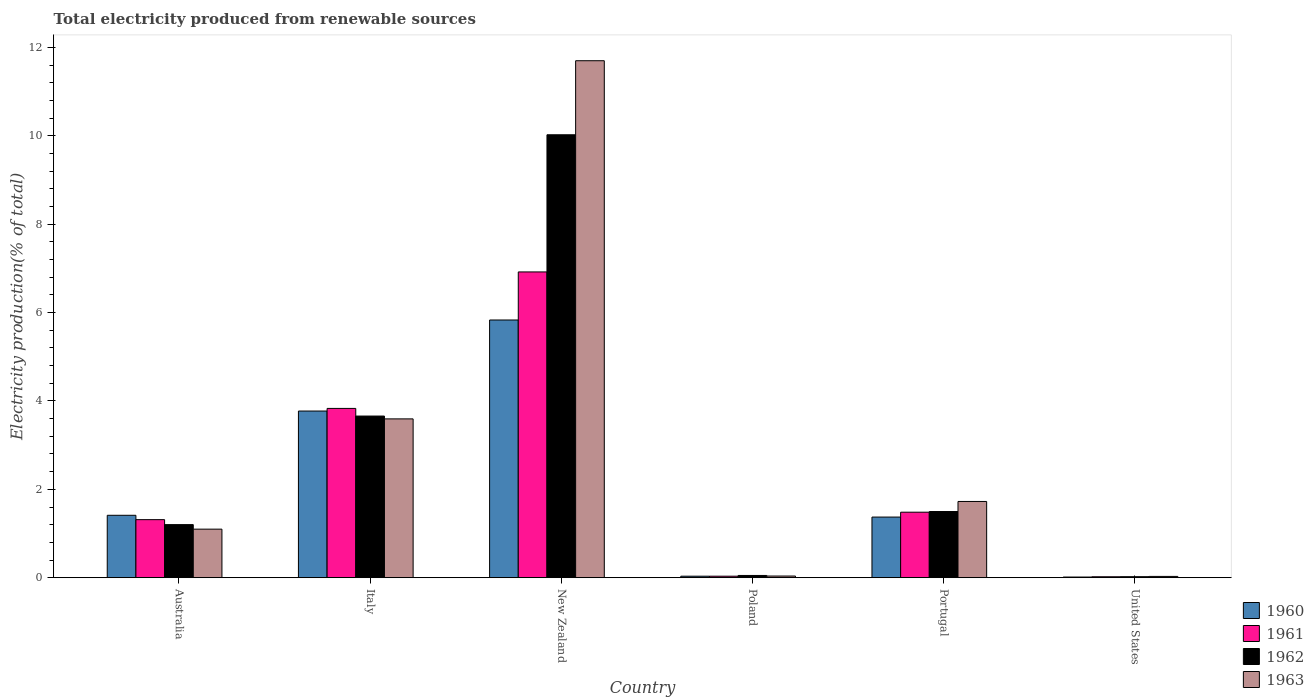How many different coloured bars are there?
Your answer should be very brief. 4. Are the number of bars per tick equal to the number of legend labels?
Your answer should be very brief. Yes. How many bars are there on the 3rd tick from the left?
Keep it short and to the point. 4. How many bars are there on the 6th tick from the right?
Give a very brief answer. 4. What is the label of the 1st group of bars from the left?
Your answer should be very brief. Australia. In how many cases, is the number of bars for a given country not equal to the number of legend labels?
Make the answer very short. 0. What is the total electricity produced in 1961 in United States?
Provide a short and direct response. 0.02. Across all countries, what is the maximum total electricity produced in 1962?
Your answer should be compact. 10.02. Across all countries, what is the minimum total electricity produced in 1963?
Offer a terse response. 0.03. In which country was the total electricity produced in 1961 maximum?
Offer a terse response. New Zealand. In which country was the total electricity produced in 1963 minimum?
Your answer should be very brief. United States. What is the total total electricity produced in 1961 in the graph?
Provide a succinct answer. 13.6. What is the difference between the total electricity produced in 1963 in Poland and that in Portugal?
Make the answer very short. -1.69. What is the difference between the total electricity produced in 1963 in Poland and the total electricity produced in 1960 in United States?
Offer a terse response. 0.02. What is the average total electricity produced in 1963 per country?
Provide a short and direct response. 3.03. What is the difference between the total electricity produced of/in 1961 and total electricity produced of/in 1963 in Poland?
Provide a succinct answer. -0. What is the ratio of the total electricity produced in 1962 in Australia to that in Italy?
Your response must be concise. 0.33. Is the difference between the total electricity produced in 1961 in Australia and New Zealand greater than the difference between the total electricity produced in 1963 in Australia and New Zealand?
Offer a terse response. Yes. What is the difference between the highest and the second highest total electricity produced in 1960?
Offer a terse response. -2.36. What is the difference between the highest and the lowest total electricity produced in 1960?
Make the answer very short. 5.82. In how many countries, is the total electricity produced in 1962 greater than the average total electricity produced in 1962 taken over all countries?
Offer a very short reply. 2. Is the sum of the total electricity produced in 1963 in Poland and United States greater than the maximum total electricity produced in 1962 across all countries?
Provide a succinct answer. No. Is it the case that in every country, the sum of the total electricity produced in 1962 and total electricity produced in 1960 is greater than the sum of total electricity produced in 1963 and total electricity produced in 1961?
Your response must be concise. No. What does the 1st bar from the right in Italy represents?
Your response must be concise. 1963. How many bars are there?
Provide a succinct answer. 24. What is the difference between two consecutive major ticks on the Y-axis?
Your answer should be very brief. 2. Are the values on the major ticks of Y-axis written in scientific E-notation?
Offer a terse response. No. Where does the legend appear in the graph?
Your answer should be very brief. Bottom right. How many legend labels are there?
Make the answer very short. 4. How are the legend labels stacked?
Provide a short and direct response. Vertical. What is the title of the graph?
Make the answer very short. Total electricity produced from renewable sources. Does "1974" appear as one of the legend labels in the graph?
Make the answer very short. No. What is the label or title of the X-axis?
Provide a succinct answer. Country. What is the label or title of the Y-axis?
Offer a very short reply. Electricity production(% of total). What is the Electricity production(% of total) of 1960 in Australia?
Your answer should be compact. 1.41. What is the Electricity production(% of total) of 1961 in Australia?
Your answer should be very brief. 1.31. What is the Electricity production(% of total) in 1962 in Australia?
Provide a succinct answer. 1.2. What is the Electricity production(% of total) of 1963 in Australia?
Make the answer very short. 1.1. What is the Electricity production(% of total) in 1960 in Italy?
Keep it short and to the point. 3.77. What is the Electricity production(% of total) of 1961 in Italy?
Provide a succinct answer. 3.83. What is the Electricity production(% of total) in 1962 in Italy?
Provide a succinct answer. 3.66. What is the Electricity production(% of total) in 1963 in Italy?
Make the answer very short. 3.59. What is the Electricity production(% of total) in 1960 in New Zealand?
Keep it short and to the point. 5.83. What is the Electricity production(% of total) in 1961 in New Zealand?
Offer a terse response. 6.92. What is the Electricity production(% of total) in 1962 in New Zealand?
Your answer should be very brief. 10.02. What is the Electricity production(% of total) of 1963 in New Zealand?
Your answer should be very brief. 11.7. What is the Electricity production(% of total) in 1960 in Poland?
Provide a succinct answer. 0.03. What is the Electricity production(% of total) of 1961 in Poland?
Ensure brevity in your answer.  0.03. What is the Electricity production(% of total) of 1962 in Poland?
Keep it short and to the point. 0.05. What is the Electricity production(% of total) in 1963 in Poland?
Make the answer very short. 0.04. What is the Electricity production(% of total) of 1960 in Portugal?
Offer a very short reply. 1.37. What is the Electricity production(% of total) of 1961 in Portugal?
Make the answer very short. 1.48. What is the Electricity production(% of total) of 1962 in Portugal?
Your response must be concise. 1.5. What is the Electricity production(% of total) in 1963 in Portugal?
Your answer should be compact. 1.73. What is the Electricity production(% of total) in 1960 in United States?
Keep it short and to the point. 0.02. What is the Electricity production(% of total) in 1961 in United States?
Your response must be concise. 0.02. What is the Electricity production(% of total) in 1962 in United States?
Your response must be concise. 0.02. What is the Electricity production(% of total) in 1963 in United States?
Provide a short and direct response. 0.03. Across all countries, what is the maximum Electricity production(% of total) of 1960?
Ensure brevity in your answer.  5.83. Across all countries, what is the maximum Electricity production(% of total) in 1961?
Ensure brevity in your answer.  6.92. Across all countries, what is the maximum Electricity production(% of total) in 1962?
Provide a succinct answer. 10.02. Across all countries, what is the maximum Electricity production(% of total) in 1963?
Make the answer very short. 11.7. Across all countries, what is the minimum Electricity production(% of total) of 1960?
Make the answer very short. 0.02. Across all countries, what is the minimum Electricity production(% of total) in 1961?
Ensure brevity in your answer.  0.02. Across all countries, what is the minimum Electricity production(% of total) of 1962?
Keep it short and to the point. 0.02. Across all countries, what is the minimum Electricity production(% of total) of 1963?
Provide a short and direct response. 0.03. What is the total Electricity production(% of total) in 1960 in the graph?
Make the answer very short. 12.44. What is the total Electricity production(% of total) in 1961 in the graph?
Give a very brief answer. 13.6. What is the total Electricity production(% of total) of 1962 in the graph?
Your answer should be compact. 16.46. What is the total Electricity production(% of total) of 1963 in the graph?
Offer a very short reply. 18.19. What is the difference between the Electricity production(% of total) of 1960 in Australia and that in Italy?
Your answer should be compact. -2.36. What is the difference between the Electricity production(% of total) of 1961 in Australia and that in Italy?
Your answer should be very brief. -2.52. What is the difference between the Electricity production(% of total) of 1962 in Australia and that in Italy?
Make the answer very short. -2.46. What is the difference between the Electricity production(% of total) of 1963 in Australia and that in Italy?
Offer a very short reply. -2.5. What is the difference between the Electricity production(% of total) in 1960 in Australia and that in New Zealand?
Your answer should be compact. -4.42. What is the difference between the Electricity production(% of total) in 1961 in Australia and that in New Zealand?
Your response must be concise. -5.61. What is the difference between the Electricity production(% of total) of 1962 in Australia and that in New Zealand?
Your response must be concise. -8.82. What is the difference between the Electricity production(% of total) of 1963 in Australia and that in New Zealand?
Your answer should be compact. -10.6. What is the difference between the Electricity production(% of total) of 1960 in Australia and that in Poland?
Offer a very short reply. 1.38. What is the difference between the Electricity production(% of total) of 1961 in Australia and that in Poland?
Provide a short and direct response. 1.28. What is the difference between the Electricity production(% of total) in 1962 in Australia and that in Poland?
Your answer should be compact. 1.15. What is the difference between the Electricity production(% of total) of 1963 in Australia and that in Poland?
Offer a terse response. 1.06. What is the difference between the Electricity production(% of total) in 1960 in Australia and that in Portugal?
Keep it short and to the point. 0.04. What is the difference between the Electricity production(% of total) in 1961 in Australia and that in Portugal?
Make the answer very short. -0.17. What is the difference between the Electricity production(% of total) of 1962 in Australia and that in Portugal?
Make the answer very short. -0.3. What is the difference between the Electricity production(% of total) of 1963 in Australia and that in Portugal?
Ensure brevity in your answer.  -0.63. What is the difference between the Electricity production(% of total) in 1960 in Australia and that in United States?
Keep it short and to the point. 1.4. What is the difference between the Electricity production(% of total) in 1961 in Australia and that in United States?
Your answer should be very brief. 1.29. What is the difference between the Electricity production(% of total) in 1962 in Australia and that in United States?
Offer a very short reply. 1.18. What is the difference between the Electricity production(% of total) of 1963 in Australia and that in United States?
Offer a very short reply. 1.07. What is the difference between the Electricity production(% of total) in 1960 in Italy and that in New Zealand?
Keep it short and to the point. -2.06. What is the difference between the Electricity production(% of total) in 1961 in Italy and that in New Zealand?
Your answer should be very brief. -3.09. What is the difference between the Electricity production(% of total) in 1962 in Italy and that in New Zealand?
Offer a very short reply. -6.37. What is the difference between the Electricity production(% of total) in 1963 in Italy and that in New Zealand?
Your response must be concise. -8.11. What is the difference between the Electricity production(% of total) in 1960 in Italy and that in Poland?
Offer a terse response. 3.74. What is the difference between the Electricity production(% of total) of 1961 in Italy and that in Poland?
Your response must be concise. 3.8. What is the difference between the Electricity production(% of total) of 1962 in Italy and that in Poland?
Offer a terse response. 3.61. What is the difference between the Electricity production(% of total) in 1963 in Italy and that in Poland?
Ensure brevity in your answer.  3.56. What is the difference between the Electricity production(% of total) in 1960 in Italy and that in Portugal?
Provide a short and direct response. 2.4. What is the difference between the Electricity production(% of total) in 1961 in Italy and that in Portugal?
Make the answer very short. 2.35. What is the difference between the Electricity production(% of total) of 1962 in Italy and that in Portugal?
Offer a terse response. 2.16. What is the difference between the Electricity production(% of total) of 1963 in Italy and that in Portugal?
Your answer should be very brief. 1.87. What is the difference between the Electricity production(% of total) of 1960 in Italy and that in United States?
Make the answer very short. 3.76. What is the difference between the Electricity production(% of total) of 1961 in Italy and that in United States?
Offer a terse response. 3.81. What is the difference between the Electricity production(% of total) of 1962 in Italy and that in United States?
Keep it short and to the point. 3.64. What is the difference between the Electricity production(% of total) in 1963 in Italy and that in United States?
Provide a succinct answer. 3.56. What is the difference between the Electricity production(% of total) in 1960 in New Zealand and that in Poland?
Your answer should be compact. 5.8. What is the difference between the Electricity production(% of total) in 1961 in New Zealand and that in Poland?
Make the answer very short. 6.89. What is the difference between the Electricity production(% of total) in 1962 in New Zealand and that in Poland?
Ensure brevity in your answer.  9.97. What is the difference between the Electricity production(% of total) of 1963 in New Zealand and that in Poland?
Give a very brief answer. 11.66. What is the difference between the Electricity production(% of total) of 1960 in New Zealand and that in Portugal?
Offer a very short reply. 4.46. What is the difference between the Electricity production(% of total) in 1961 in New Zealand and that in Portugal?
Provide a short and direct response. 5.44. What is the difference between the Electricity production(% of total) of 1962 in New Zealand and that in Portugal?
Your answer should be compact. 8.53. What is the difference between the Electricity production(% of total) in 1963 in New Zealand and that in Portugal?
Keep it short and to the point. 9.97. What is the difference between the Electricity production(% of total) in 1960 in New Zealand and that in United States?
Provide a short and direct response. 5.82. What is the difference between the Electricity production(% of total) of 1961 in New Zealand and that in United States?
Make the answer very short. 6.9. What is the difference between the Electricity production(% of total) in 1962 in New Zealand and that in United States?
Your response must be concise. 10. What is the difference between the Electricity production(% of total) of 1963 in New Zealand and that in United States?
Give a very brief answer. 11.67. What is the difference between the Electricity production(% of total) in 1960 in Poland and that in Portugal?
Offer a very short reply. -1.34. What is the difference between the Electricity production(% of total) of 1961 in Poland and that in Portugal?
Offer a terse response. -1.45. What is the difference between the Electricity production(% of total) of 1962 in Poland and that in Portugal?
Your answer should be compact. -1.45. What is the difference between the Electricity production(% of total) of 1963 in Poland and that in Portugal?
Offer a terse response. -1.69. What is the difference between the Electricity production(% of total) in 1960 in Poland and that in United States?
Offer a very short reply. 0.02. What is the difference between the Electricity production(% of total) of 1961 in Poland and that in United States?
Provide a succinct answer. 0.01. What is the difference between the Electricity production(% of total) in 1962 in Poland and that in United States?
Make the answer very short. 0.03. What is the difference between the Electricity production(% of total) in 1963 in Poland and that in United States?
Offer a very short reply. 0.01. What is the difference between the Electricity production(% of total) of 1960 in Portugal and that in United States?
Provide a short and direct response. 1.36. What is the difference between the Electricity production(% of total) in 1961 in Portugal and that in United States?
Your response must be concise. 1.46. What is the difference between the Electricity production(% of total) in 1962 in Portugal and that in United States?
Give a very brief answer. 1.48. What is the difference between the Electricity production(% of total) of 1963 in Portugal and that in United States?
Keep it short and to the point. 1.7. What is the difference between the Electricity production(% of total) of 1960 in Australia and the Electricity production(% of total) of 1961 in Italy?
Ensure brevity in your answer.  -2.42. What is the difference between the Electricity production(% of total) of 1960 in Australia and the Electricity production(% of total) of 1962 in Italy?
Give a very brief answer. -2.25. What is the difference between the Electricity production(% of total) of 1960 in Australia and the Electricity production(% of total) of 1963 in Italy?
Provide a short and direct response. -2.18. What is the difference between the Electricity production(% of total) of 1961 in Australia and the Electricity production(% of total) of 1962 in Italy?
Provide a succinct answer. -2.34. What is the difference between the Electricity production(% of total) in 1961 in Australia and the Electricity production(% of total) in 1963 in Italy?
Offer a very short reply. -2.28. What is the difference between the Electricity production(% of total) of 1962 in Australia and the Electricity production(% of total) of 1963 in Italy?
Your response must be concise. -2.39. What is the difference between the Electricity production(% of total) of 1960 in Australia and the Electricity production(% of total) of 1961 in New Zealand?
Your answer should be very brief. -5.51. What is the difference between the Electricity production(% of total) in 1960 in Australia and the Electricity production(% of total) in 1962 in New Zealand?
Make the answer very short. -8.61. What is the difference between the Electricity production(% of total) of 1960 in Australia and the Electricity production(% of total) of 1963 in New Zealand?
Provide a succinct answer. -10.29. What is the difference between the Electricity production(% of total) in 1961 in Australia and the Electricity production(% of total) in 1962 in New Zealand?
Offer a very short reply. -8.71. What is the difference between the Electricity production(% of total) of 1961 in Australia and the Electricity production(% of total) of 1963 in New Zealand?
Make the answer very short. -10.39. What is the difference between the Electricity production(% of total) in 1962 in Australia and the Electricity production(% of total) in 1963 in New Zealand?
Offer a terse response. -10.5. What is the difference between the Electricity production(% of total) of 1960 in Australia and the Electricity production(% of total) of 1961 in Poland?
Your answer should be very brief. 1.38. What is the difference between the Electricity production(% of total) of 1960 in Australia and the Electricity production(% of total) of 1962 in Poland?
Keep it short and to the point. 1.36. What is the difference between the Electricity production(% of total) of 1960 in Australia and the Electricity production(% of total) of 1963 in Poland?
Make the answer very short. 1.37. What is the difference between the Electricity production(% of total) of 1961 in Australia and the Electricity production(% of total) of 1962 in Poland?
Keep it short and to the point. 1.26. What is the difference between the Electricity production(% of total) of 1961 in Australia and the Electricity production(% of total) of 1963 in Poland?
Your answer should be compact. 1.28. What is the difference between the Electricity production(% of total) of 1962 in Australia and the Electricity production(% of total) of 1963 in Poland?
Make the answer very short. 1.16. What is the difference between the Electricity production(% of total) of 1960 in Australia and the Electricity production(% of total) of 1961 in Portugal?
Your answer should be very brief. -0.07. What is the difference between the Electricity production(% of total) in 1960 in Australia and the Electricity production(% of total) in 1962 in Portugal?
Offer a very short reply. -0.09. What is the difference between the Electricity production(% of total) of 1960 in Australia and the Electricity production(% of total) of 1963 in Portugal?
Your response must be concise. -0.31. What is the difference between the Electricity production(% of total) of 1961 in Australia and the Electricity production(% of total) of 1962 in Portugal?
Ensure brevity in your answer.  -0.18. What is the difference between the Electricity production(% of total) of 1961 in Australia and the Electricity production(% of total) of 1963 in Portugal?
Give a very brief answer. -0.41. What is the difference between the Electricity production(% of total) of 1962 in Australia and the Electricity production(% of total) of 1963 in Portugal?
Provide a short and direct response. -0.52. What is the difference between the Electricity production(% of total) of 1960 in Australia and the Electricity production(% of total) of 1961 in United States?
Your response must be concise. 1.39. What is the difference between the Electricity production(% of total) of 1960 in Australia and the Electricity production(% of total) of 1962 in United States?
Offer a terse response. 1.39. What is the difference between the Electricity production(% of total) of 1960 in Australia and the Electricity production(% of total) of 1963 in United States?
Provide a succinct answer. 1.38. What is the difference between the Electricity production(% of total) of 1961 in Australia and the Electricity production(% of total) of 1962 in United States?
Your answer should be very brief. 1.29. What is the difference between the Electricity production(% of total) of 1961 in Australia and the Electricity production(% of total) of 1963 in United States?
Offer a very short reply. 1.28. What is the difference between the Electricity production(% of total) in 1962 in Australia and the Electricity production(% of total) in 1963 in United States?
Offer a very short reply. 1.17. What is the difference between the Electricity production(% of total) of 1960 in Italy and the Electricity production(% of total) of 1961 in New Zealand?
Keep it short and to the point. -3.15. What is the difference between the Electricity production(% of total) in 1960 in Italy and the Electricity production(% of total) in 1962 in New Zealand?
Provide a short and direct response. -6.25. What is the difference between the Electricity production(% of total) in 1960 in Italy and the Electricity production(% of total) in 1963 in New Zealand?
Provide a short and direct response. -7.93. What is the difference between the Electricity production(% of total) in 1961 in Italy and the Electricity production(% of total) in 1962 in New Zealand?
Your answer should be compact. -6.19. What is the difference between the Electricity production(% of total) in 1961 in Italy and the Electricity production(% of total) in 1963 in New Zealand?
Give a very brief answer. -7.87. What is the difference between the Electricity production(% of total) of 1962 in Italy and the Electricity production(% of total) of 1963 in New Zealand?
Provide a succinct answer. -8.04. What is the difference between the Electricity production(% of total) in 1960 in Italy and the Electricity production(% of total) in 1961 in Poland?
Make the answer very short. 3.74. What is the difference between the Electricity production(% of total) in 1960 in Italy and the Electricity production(% of total) in 1962 in Poland?
Give a very brief answer. 3.72. What is the difference between the Electricity production(% of total) of 1960 in Italy and the Electricity production(% of total) of 1963 in Poland?
Ensure brevity in your answer.  3.73. What is the difference between the Electricity production(% of total) in 1961 in Italy and the Electricity production(% of total) in 1962 in Poland?
Provide a short and direct response. 3.78. What is the difference between the Electricity production(% of total) of 1961 in Italy and the Electricity production(% of total) of 1963 in Poland?
Provide a succinct answer. 3.79. What is the difference between the Electricity production(% of total) in 1962 in Italy and the Electricity production(% of total) in 1963 in Poland?
Your answer should be compact. 3.62. What is the difference between the Electricity production(% of total) of 1960 in Italy and the Electricity production(% of total) of 1961 in Portugal?
Make the answer very short. 2.29. What is the difference between the Electricity production(% of total) of 1960 in Italy and the Electricity production(% of total) of 1962 in Portugal?
Provide a short and direct response. 2.27. What is the difference between the Electricity production(% of total) in 1960 in Italy and the Electricity production(% of total) in 1963 in Portugal?
Provide a succinct answer. 2.05. What is the difference between the Electricity production(% of total) in 1961 in Italy and the Electricity production(% of total) in 1962 in Portugal?
Provide a short and direct response. 2.33. What is the difference between the Electricity production(% of total) of 1961 in Italy and the Electricity production(% of total) of 1963 in Portugal?
Your response must be concise. 2.11. What is the difference between the Electricity production(% of total) in 1962 in Italy and the Electricity production(% of total) in 1963 in Portugal?
Your answer should be very brief. 1.93. What is the difference between the Electricity production(% of total) of 1960 in Italy and the Electricity production(% of total) of 1961 in United States?
Make the answer very short. 3.75. What is the difference between the Electricity production(% of total) in 1960 in Italy and the Electricity production(% of total) in 1962 in United States?
Your response must be concise. 3.75. What is the difference between the Electricity production(% of total) in 1960 in Italy and the Electricity production(% of total) in 1963 in United States?
Give a very brief answer. 3.74. What is the difference between the Electricity production(% of total) of 1961 in Italy and the Electricity production(% of total) of 1962 in United States?
Your answer should be very brief. 3.81. What is the difference between the Electricity production(% of total) in 1961 in Italy and the Electricity production(% of total) in 1963 in United States?
Provide a succinct answer. 3.8. What is the difference between the Electricity production(% of total) of 1962 in Italy and the Electricity production(% of total) of 1963 in United States?
Provide a succinct answer. 3.63. What is the difference between the Electricity production(% of total) in 1960 in New Zealand and the Electricity production(% of total) in 1961 in Poland?
Offer a very short reply. 5.8. What is the difference between the Electricity production(% of total) of 1960 in New Zealand and the Electricity production(% of total) of 1962 in Poland?
Your answer should be compact. 5.78. What is the difference between the Electricity production(% of total) of 1960 in New Zealand and the Electricity production(% of total) of 1963 in Poland?
Offer a terse response. 5.79. What is the difference between the Electricity production(% of total) of 1961 in New Zealand and the Electricity production(% of total) of 1962 in Poland?
Your answer should be very brief. 6.87. What is the difference between the Electricity production(% of total) in 1961 in New Zealand and the Electricity production(% of total) in 1963 in Poland?
Ensure brevity in your answer.  6.88. What is the difference between the Electricity production(% of total) of 1962 in New Zealand and the Electricity production(% of total) of 1963 in Poland?
Keep it short and to the point. 9.99. What is the difference between the Electricity production(% of total) in 1960 in New Zealand and the Electricity production(% of total) in 1961 in Portugal?
Provide a short and direct response. 4.35. What is the difference between the Electricity production(% of total) of 1960 in New Zealand and the Electricity production(% of total) of 1962 in Portugal?
Your response must be concise. 4.33. What is the difference between the Electricity production(% of total) of 1960 in New Zealand and the Electricity production(% of total) of 1963 in Portugal?
Ensure brevity in your answer.  4.11. What is the difference between the Electricity production(% of total) of 1961 in New Zealand and the Electricity production(% of total) of 1962 in Portugal?
Keep it short and to the point. 5.42. What is the difference between the Electricity production(% of total) of 1961 in New Zealand and the Electricity production(% of total) of 1963 in Portugal?
Your answer should be very brief. 5.19. What is the difference between the Electricity production(% of total) in 1962 in New Zealand and the Electricity production(% of total) in 1963 in Portugal?
Your response must be concise. 8.3. What is the difference between the Electricity production(% of total) of 1960 in New Zealand and the Electricity production(% of total) of 1961 in United States?
Give a very brief answer. 5.81. What is the difference between the Electricity production(% of total) of 1960 in New Zealand and the Electricity production(% of total) of 1962 in United States?
Your answer should be compact. 5.81. What is the difference between the Electricity production(% of total) of 1960 in New Zealand and the Electricity production(% of total) of 1963 in United States?
Offer a very short reply. 5.8. What is the difference between the Electricity production(% of total) in 1961 in New Zealand and the Electricity production(% of total) in 1962 in United States?
Keep it short and to the point. 6.9. What is the difference between the Electricity production(% of total) of 1961 in New Zealand and the Electricity production(% of total) of 1963 in United States?
Make the answer very short. 6.89. What is the difference between the Electricity production(% of total) of 1962 in New Zealand and the Electricity production(% of total) of 1963 in United States?
Give a very brief answer. 10. What is the difference between the Electricity production(% of total) in 1960 in Poland and the Electricity production(% of total) in 1961 in Portugal?
Ensure brevity in your answer.  -1.45. What is the difference between the Electricity production(% of total) of 1960 in Poland and the Electricity production(% of total) of 1962 in Portugal?
Give a very brief answer. -1.46. What is the difference between the Electricity production(% of total) of 1960 in Poland and the Electricity production(% of total) of 1963 in Portugal?
Provide a succinct answer. -1.69. What is the difference between the Electricity production(% of total) of 1961 in Poland and the Electricity production(% of total) of 1962 in Portugal?
Your answer should be very brief. -1.46. What is the difference between the Electricity production(% of total) of 1961 in Poland and the Electricity production(% of total) of 1963 in Portugal?
Keep it short and to the point. -1.69. What is the difference between the Electricity production(% of total) in 1962 in Poland and the Electricity production(% of total) in 1963 in Portugal?
Your answer should be compact. -1.67. What is the difference between the Electricity production(% of total) in 1960 in Poland and the Electricity production(% of total) in 1961 in United States?
Offer a very short reply. 0.01. What is the difference between the Electricity production(% of total) in 1960 in Poland and the Electricity production(% of total) in 1962 in United States?
Ensure brevity in your answer.  0.01. What is the difference between the Electricity production(% of total) in 1960 in Poland and the Electricity production(% of total) in 1963 in United States?
Keep it short and to the point. 0. What is the difference between the Electricity production(% of total) in 1961 in Poland and the Electricity production(% of total) in 1962 in United States?
Provide a short and direct response. 0.01. What is the difference between the Electricity production(% of total) of 1961 in Poland and the Electricity production(% of total) of 1963 in United States?
Ensure brevity in your answer.  0. What is the difference between the Electricity production(% of total) of 1962 in Poland and the Electricity production(% of total) of 1963 in United States?
Offer a very short reply. 0.02. What is the difference between the Electricity production(% of total) of 1960 in Portugal and the Electricity production(% of total) of 1961 in United States?
Provide a short and direct response. 1.35. What is the difference between the Electricity production(% of total) in 1960 in Portugal and the Electricity production(% of total) in 1962 in United States?
Your response must be concise. 1.35. What is the difference between the Electricity production(% of total) in 1960 in Portugal and the Electricity production(% of total) in 1963 in United States?
Your response must be concise. 1.34. What is the difference between the Electricity production(% of total) of 1961 in Portugal and the Electricity production(% of total) of 1962 in United States?
Provide a succinct answer. 1.46. What is the difference between the Electricity production(% of total) of 1961 in Portugal and the Electricity production(% of total) of 1963 in United States?
Keep it short and to the point. 1.45. What is the difference between the Electricity production(% of total) of 1962 in Portugal and the Electricity production(% of total) of 1963 in United States?
Your response must be concise. 1.47. What is the average Electricity production(% of total) of 1960 per country?
Make the answer very short. 2.07. What is the average Electricity production(% of total) in 1961 per country?
Provide a succinct answer. 2.27. What is the average Electricity production(% of total) of 1962 per country?
Keep it short and to the point. 2.74. What is the average Electricity production(% of total) in 1963 per country?
Offer a terse response. 3.03. What is the difference between the Electricity production(% of total) in 1960 and Electricity production(% of total) in 1961 in Australia?
Ensure brevity in your answer.  0.1. What is the difference between the Electricity production(% of total) in 1960 and Electricity production(% of total) in 1962 in Australia?
Offer a terse response. 0.21. What is the difference between the Electricity production(% of total) in 1960 and Electricity production(% of total) in 1963 in Australia?
Your response must be concise. 0.31. What is the difference between the Electricity production(% of total) in 1961 and Electricity production(% of total) in 1962 in Australia?
Give a very brief answer. 0.11. What is the difference between the Electricity production(% of total) in 1961 and Electricity production(% of total) in 1963 in Australia?
Your answer should be compact. 0.21. What is the difference between the Electricity production(% of total) in 1962 and Electricity production(% of total) in 1963 in Australia?
Offer a terse response. 0.1. What is the difference between the Electricity production(% of total) of 1960 and Electricity production(% of total) of 1961 in Italy?
Offer a very short reply. -0.06. What is the difference between the Electricity production(% of total) of 1960 and Electricity production(% of total) of 1962 in Italy?
Your answer should be compact. 0.11. What is the difference between the Electricity production(% of total) in 1960 and Electricity production(% of total) in 1963 in Italy?
Provide a succinct answer. 0.18. What is the difference between the Electricity production(% of total) in 1961 and Electricity production(% of total) in 1962 in Italy?
Offer a terse response. 0.17. What is the difference between the Electricity production(% of total) of 1961 and Electricity production(% of total) of 1963 in Italy?
Your answer should be very brief. 0.24. What is the difference between the Electricity production(% of total) in 1962 and Electricity production(% of total) in 1963 in Italy?
Offer a terse response. 0.06. What is the difference between the Electricity production(% of total) of 1960 and Electricity production(% of total) of 1961 in New Zealand?
Provide a succinct answer. -1.09. What is the difference between the Electricity production(% of total) of 1960 and Electricity production(% of total) of 1962 in New Zealand?
Your answer should be compact. -4.19. What is the difference between the Electricity production(% of total) in 1960 and Electricity production(% of total) in 1963 in New Zealand?
Your response must be concise. -5.87. What is the difference between the Electricity production(% of total) in 1961 and Electricity production(% of total) in 1962 in New Zealand?
Provide a succinct answer. -3.1. What is the difference between the Electricity production(% of total) of 1961 and Electricity production(% of total) of 1963 in New Zealand?
Your response must be concise. -4.78. What is the difference between the Electricity production(% of total) of 1962 and Electricity production(% of total) of 1963 in New Zealand?
Your response must be concise. -1.68. What is the difference between the Electricity production(% of total) in 1960 and Electricity production(% of total) in 1961 in Poland?
Your answer should be compact. 0. What is the difference between the Electricity production(% of total) of 1960 and Electricity production(% of total) of 1962 in Poland?
Ensure brevity in your answer.  -0.02. What is the difference between the Electricity production(% of total) of 1960 and Electricity production(% of total) of 1963 in Poland?
Make the answer very short. -0. What is the difference between the Electricity production(% of total) in 1961 and Electricity production(% of total) in 1962 in Poland?
Give a very brief answer. -0.02. What is the difference between the Electricity production(% of total) in 1961 and Electricity production(% of total) in 1963 in Poland?
Give a very brief answer. -0. What is the difference between the Electricity production(% of total) of 1962 and Electricity production(% of total) of 1963 in Poland?
Your answer should be very brief. 0.01. What is the difference between the Electricity production(% of total) in 1960 and Electricity production(% of total) in 1961 in Portugal?
Provide a short and direct response. -0.11. What is the difference between the Electricity production(% of total) of 1960 and Electricity production(% of total) of 1962 in Portugal?
Ensure brevity in your answer.  -0.13. What is the difference between the Electricity production(% of total) of 1960 and Electricity production(% of total) of 1963 in Portugal?
Make the answer very short. -0.35. What is the difference between the Electricity production(% of total) of 1961 and Electricity production(% of total) of 1962 in Portugal?
Your response must be concise. -0.02. What is the difference between the Electricity production(% of total) in 1961 and Electricity production(% of total) in 1963 in Portugal?
Ensure brevity in your answer.  -0.24. What is the difference between the Electricity production(% of total) in 1962 and Electricity production(% of total) in 1963 in Portugal?
Your answer should be compact. -0.23. What is the difference between the Electricity production(% of total) in 1960 and Electricity production(% of total) in 1961 in United States?
Your answer should be compact. -0.01. What is the difference between the Electricity production(% of total) of 1960 and Electricity production(% of total) of 1962 in United States?
Offer a terse response. -0.01. What is the difference between the Electricity production(% of total) of 1960 and Electricity production(% of total) of 1963 in United States?
Provide a succinct answer. -0.01. What is the difference between the Electricity production(% of total) of 1961 and Electricity production(% of total) of 1962 in United States?
Give a very brief answer. -0. What is the difference between the Electricity production(% of total) in 1961 and Electricity production(% of total) in 1963 in United States?
Give a very brief answer. -0.01. What is the difference between the Electricity production(% of total) in 1962 and Electricity production(% of total) in 1963 in United States?
Your response must be concise. -0.01. What is the ratio of the Electricity production(% of total) in 1960 in Australia to that in Italy?
Offer a terse response. 0.37. What is the ratio of the Electricity production(% of total) of 1961 in Australia to that in Italy?
Offer a very short reply. 0.34. What is the ratio of the Electricity production(% of total) of 1962 in Australia to that in Italy?
Offer a very short reply. 0.33. What is the ratio of the Electricity production(% of total) of 1963 in Australia to that in Italy?
Make the answer very short. 0.31. What is the ratio of the Electricity production(% of total) in 1960 in Australia to that in New Zealand?
Give a very brief answer. 0.24. What is the ratio of the Electricity production(% of total) in 1961 in Australia to that in New Zealand?
Your answer should be very brief. 0.19. What is the ratio of the Electricity production(% of total) of 1962 in Australia to that in New Zealand?
Provide a succinct answer. 0.12. What is the ratio of the Electricity production(% of total) in 1963 in Australia to that in New Zealand?
Your response must be concise. 0.09. What is the ratio of the Electricity production(% of total) of 1960 in Australia to that in Poland?
Your answer should be very brief. 41.37. What is the ratio of the Electricity production(% of total) in 1961 in Australia to that in Poland?
Make the answer very short. 38.51. What is the ratio of the Electricity production(% of total) in 1962 in Australia to that in Poland?
Make the answer very short. 23.61. What is the ratio of the Electricity production(% of total) of 1963 in Australia to that in Poland?
Your answer should be very brief. 29. What is the ratio of the Electricity production(% of total) in 1960 in Australia to that in Portugal?
Ensure brevity in your answer.  1.03. What is the ratio of the Electricity production(% of total) in 1961 in Australia to that in Portugal?
Your answer should be very brief. 0.89. What is the ratio of the Electricity production(% of total) of 1962 in Australia to that in Portugal?
Your answer should be very brief. 0.8. What is the ratio of the Electricity production(% of total) in 1963 in Australia to that in Portugal?
Your answer should be very brief. 0.64. What is the ratio of the Electricity production(% of total) of 1960 in Australia to that in United States?
Provide a short and direct response. 92.6. What is the ratio of the Electricity production(% of total) in 1961 in Australia to that in United States?
Offer a very short reply. 61. What is the ratio of the Electricity production(% of total) in 1962 in Australia to that in United States?
Your answer should be very brief. 52.74. What is the ratio of the Electricity production(% of total) in 1963 in Australia to that in United States?
Offer a very short reply. 37.34. What is the ratio of the Electricity production(% of total) of 1960 in Italy to that in New Zealand?
Your answer should be very brief. 0.65. What is the ratio of the Electricity production(% of total) in 1961 in Italy to that in New Zealand?
Give a very brief answer. 0.55. What is the ratio of the Electricity production(% of total) of 1962 in Italy to that in New Zealand?
Your response must be concise. 0.36. What is the ratio of the Electricity production(% of total) of 1963 in Italy to that in New Zealand?
Provide a succinct answer. 0.31. What is the ratio of the Electricity production(% of total) in 1960 in Italy to that in Poland?
Your answer should be very brief. 110.45. What is the ratio of the Electricity production(% of total) of 1961 in Italy to that in Poland?
Offer a very short reply. 112.3. What is the ratio of the Electricity production(% of total) of 1962 in Italy to that in Poland?
Provide a short and direct response. 71.88. What is the ratio of the Electricity production(% of total) of 1963 in Italy to that in Poland?
Provide a succinct answer. 94.84. What is the ratio of the Electricity production(% of total) of 1960 in Italy to that in Portugal?
Keep it short and to the point. 2.75. What is the ratio of the Electricity production(% of total) in 1961 in Italy to that in Portugal?
Your response must be concise. 2.58. What is the ratio of the Electricity production(% of total) in 1962 in Italy to that in Portugal?
Give a very brief answer. 2.44. What is the ratio of the Electricity production(% of total) in 1963 in Italy to that in Portugal?
Your answer should be compact. 2.08. What is the ratio of the Electricity production(% of total) of 1960 in Italy to that in United States?
Your response must be concise. 247.25. What is the ratio of the Electricity production(% of total) of 1961 in Italy to that in United States?
Offer a very short reply. 177.87. What is the ratio of the Electricity production(% of total) in 1962 in Italy to that in United States?
Your answer should be very brief. 160.56. What is the ratio of the Electricity production(% of total) in 1963 in Italy to that in United States?
Make the answer very short. 122.12. What is the ratio of the Electricity production(% of total) of 1960 in New Zealand to that in Poland?
Ensure brevity in your answer.  170.79. What is the ratio of the Electricity production(% of total) in 1961 in New Zealand to that in Poland?
Offer a terse response. 202.83. What is the ratio of the Electricity production(% of total) of 1962 in New Zealand to that in Poland?
Give a very brief answer. 196.95. What is the ratio of the Electricity production(% of total) in 1963 in New Zealand to that in Poland?
Keep it short and to the point. 308.73. What is the ratio of the Electricity production(% of total) in 1960 in New Zealand to that in Portugal?
Keep it short and to the point. 4.25. What is the ratio of the Electricity production(% of total) of 1961 in New Zealand to that in Portugal?
Give a very brief answer. 4.67. What is the ratio of the Electricity production(% of total) in 1962 in New Zealand to that in Portugal?
Your response must be concise. 6.69. What is the ratio of the Electricity production(% of total) of 1963 in New Zealand to that in Portugal?
Give a very brief answer. 6.78. What is the ratio of the Electricity production(% of total) of 1960 in New Zealand to that in United States?
Provide a succinct answer. 382.31. What is the ratio of the Electricity production(% of total) in 1961 in New Zealand to that in United States?
Offer a very short reply. 321.25. What is the ratio of the Electricity production(% of total) of 1962 in New Zealand to that in United States?
Make the answer very short. 439.93. What is the ratio of the Electricity production(% of total) of 1963 in New Zealand to that in United States?
Offer a very short reply. 397.5. What is the ratio of the Electricity production(% of total) in 1960 in Poland to that in Portugal?
Keep it short and to the point. 0.02. What is the ratio of the Electricity production(% of total) of 1961 in Poland to that in Portugal?
Give a very brief answer. 0.02. What is the ratio of the Electricity production(% of total) of 1962 in Poland to that in Portugal?
Keep it short and to the point. 0.03. What is the ratio of the Electricity production(% of total) in 1963 in Poland to that in Portugal?
Keep it short and to the point. 0.02. What is the ratio of the Electricity production(% of total) in 1960 in Poland to that in United States?
Your response must be concise. 2.24. What is the ratio of the Electricity production(% of total) in 1961 in Poland to that in United States?
Your response must be concise. 1.58. What is the ratio of the Electricity production(% of total) in 1962 in Poland to that in United States?
Your answer should be very brief. 2.23. What is the ratio of the Electricity production(% of total) in 1963 in Poland to that in United States?
Your answer should be very brief. 1.29. What is the ratio of the Electricity production(% of total) in 1960 in Portugal to that in United States?
Your answer should be compact. 89.96. What is the ratio of the Electricity production(% of total) in 1961 in Portugal to that in United States?
Give a very brief answer. 68.83. What is the ratio of the Electricity production(% of total) in 1962 in Portugal to that in United States?
Ensure brevity in your answer.  65.74. What is the ratio of the Electricity production(% of total) of 1963 in Portugal to that in United States?
Make the answer very short. 58.63. What is the difference between the highest and the second highest Electricity production(% of total) in 1960?
Your answer should be compact. 2.06. What is the difference between the highest and the second highest Electricity production(% of total) in 1961?
Your answer should be compact. 3.09. What is the difference between the highest and the second highest Electricity production(% of total) in 1962?
Provide a short and direct response. 6.37. What is the difference between the highest and the second highest Electricity production(% of total) in 1963?
Make the answer very short. 8.11. What is the difference between the highest and the lowest Electricity production(% of total) of 1960?
Your response must be concise. 5.82. What is the difference between the highest and the lowest Electricity production(% of total) in 1961?
Offer a very short reply. 6.9. What is the difference between the highest and the lowest Electricity production(% of total) of 1962?
Make the answer very short. 10. What is the difference between the highest and the lowest Electricity production(% of total) in 1963?
Make the answer very short. 11.67. 